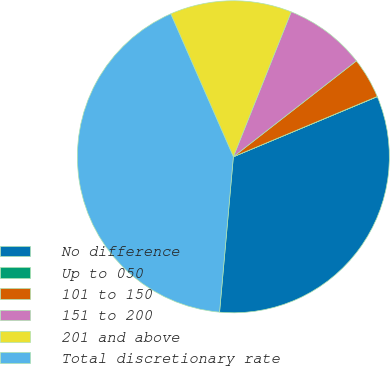Convert chart. <chart><loc_0><loc_0><loc_500><loc_500><pie_chart><fcel>No difference<fcel>Up to 050<fcel>101 to 150<fcel>151 to 200<fcel>201 and above<fcel>Total discretionary rate<nl><fcel>32.71%<fcel>0.02%<fcel>4.22%<fcel>8.42%<fcel>12.62%<fcel>42.02%<nl></chart> 